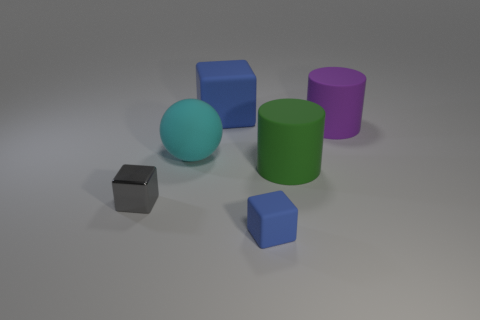How many other things are the same color as the large rubber block?
Give a very brief answer. 1. What number of other objects are the same shape as the big blue rubber object?
Make the answer very short. 2. There is a object behind the purple cylinder; does it have the same shape as the rubber object that is right of the green cylinder?
Ensure brevity in your answer.  No. Are there the same number of balls in front of the cyan thing and large green rubber cylinders behind the green rubber thing?
Your response must be concise. Yes. There is a small object that is in front of the tiny object that is on the left side of the blue object that is to the left of the small blue matte thing; what is its shape?
Provide a short and direct response. Cube. Is the blue block that is in front of the cyan object made of the same material as the thing behind the large purple matte thing?
Keep it short and to the point. Yes. There is a small object that is on the right side of the cyan thing; what is its shape?
Your answer should be very brief. Cube. Is the number of metallic things less than the number of small red blocks?
Your response must be concise. No. There is a blue matte thing to the left of the blue rubber thing that is to the right of the big blue object; are there any large rubber spheres to the right of it?
Offer a terse response. No. How many metallic objects are either big green cylinders or big purple cubes?
Offer a terse response. 0. 